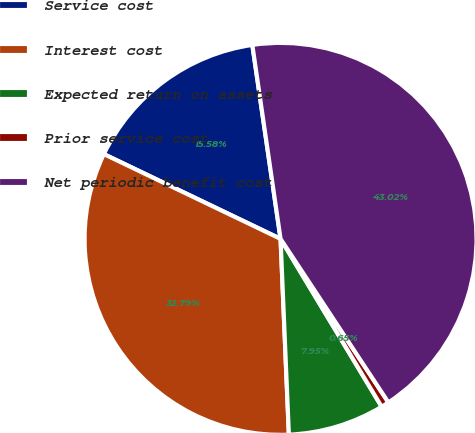Convert chart to OTSL. <chart><loc_0><loc_0><loc_500><loc_500><pie_chart><fcel>Service cost<fcel>Interest cost<fcel>Expected return on assets<fcel>Prior service cost<fcel>Net periodic benefit cost<nl><fcel>15.58%<fcel>32.79%<fcel>7.95%<fcel>0.65%<fcel>43.02%<nl></chart> 